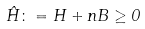<formula> <loc_0><loc_0><loc_500><loc_500>\hat { H } \colon = H + n B \geq 0</formula> 